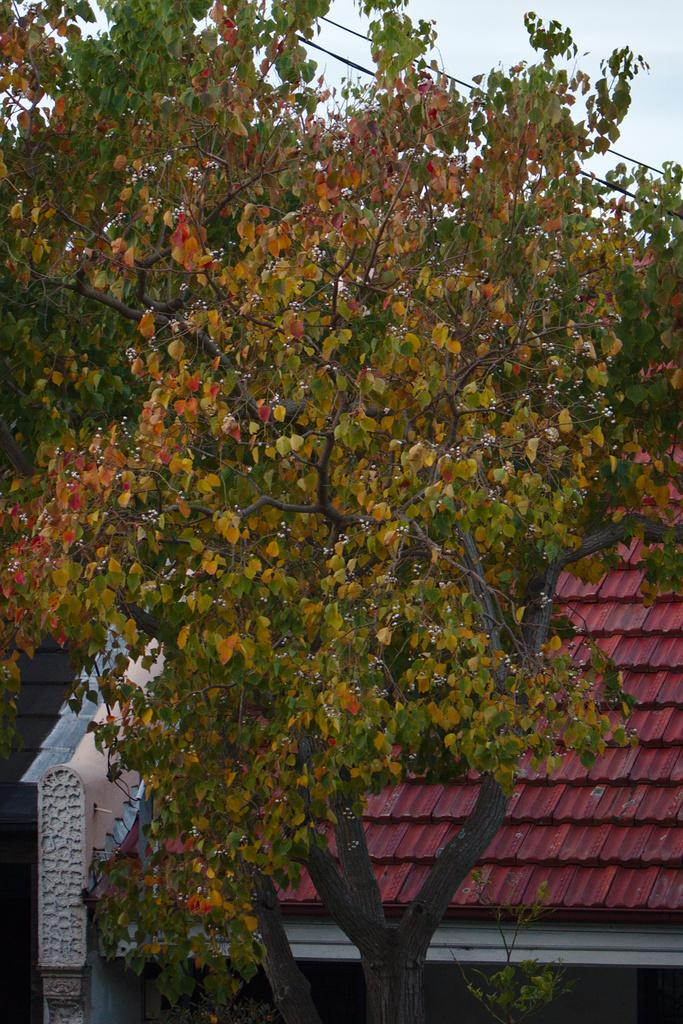What structure is visible in the image? There is a roof in the image. What type of vegetation can be seen in the image? There is a tree in the image. What is visible in the background of the image? The sky is visible in the background of the image. Can you see a cap hanging from the tree in the image? There is no cap present in the image; it only features a roof, a tree, and the sky. Is there a locket hanging from the tree in the image? There is no locket present in the image; it only features a roof, a tree, and the sky. 